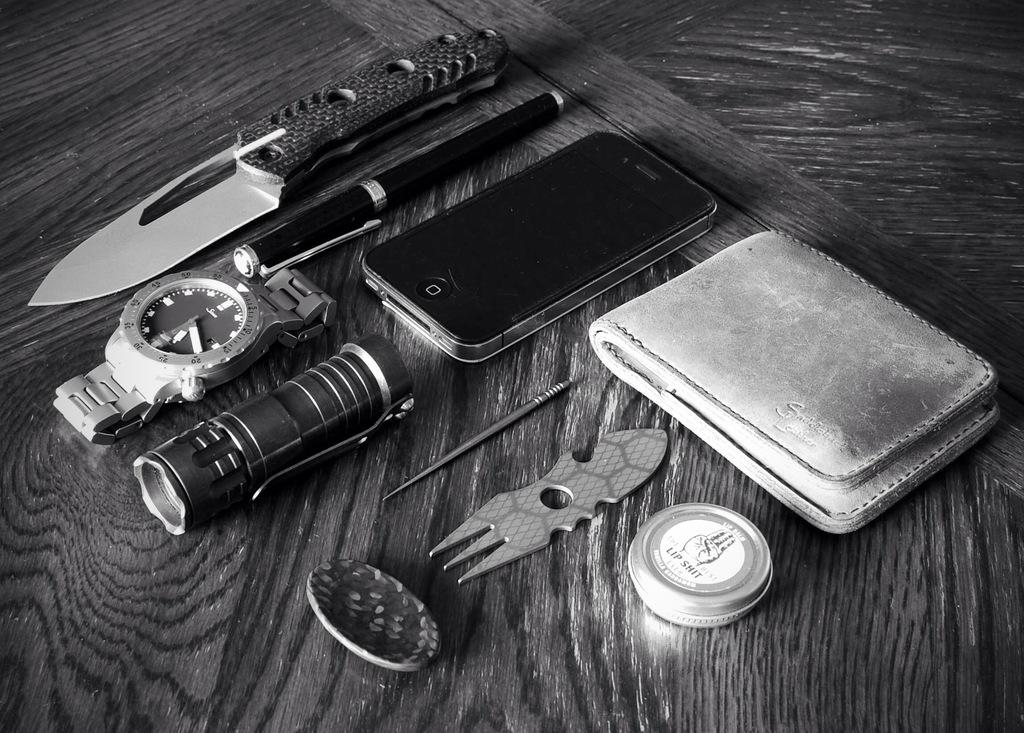<image>
Provide a brief description of the given image. A knife, a watch and some other items on a table. The word Lip is seen in a circular item. 